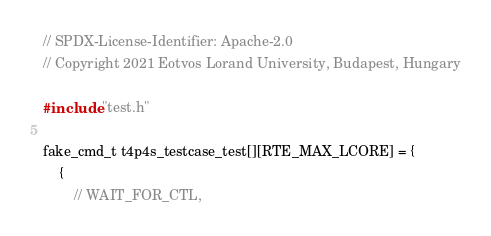<code> <loc_0><loc_0><loc_500><loc_500><_C_>// SPDX-License-Identifier: Apache-2.0
// Copyright 2021 Eotvos Lorand University, Budapest, Hungary

#include "test.h"

fake_cmd_t t4p4s_testcase_test[][RTE_MAX_LCORE] = {
    {
        // WAIT_FOR_CTL,</code> 